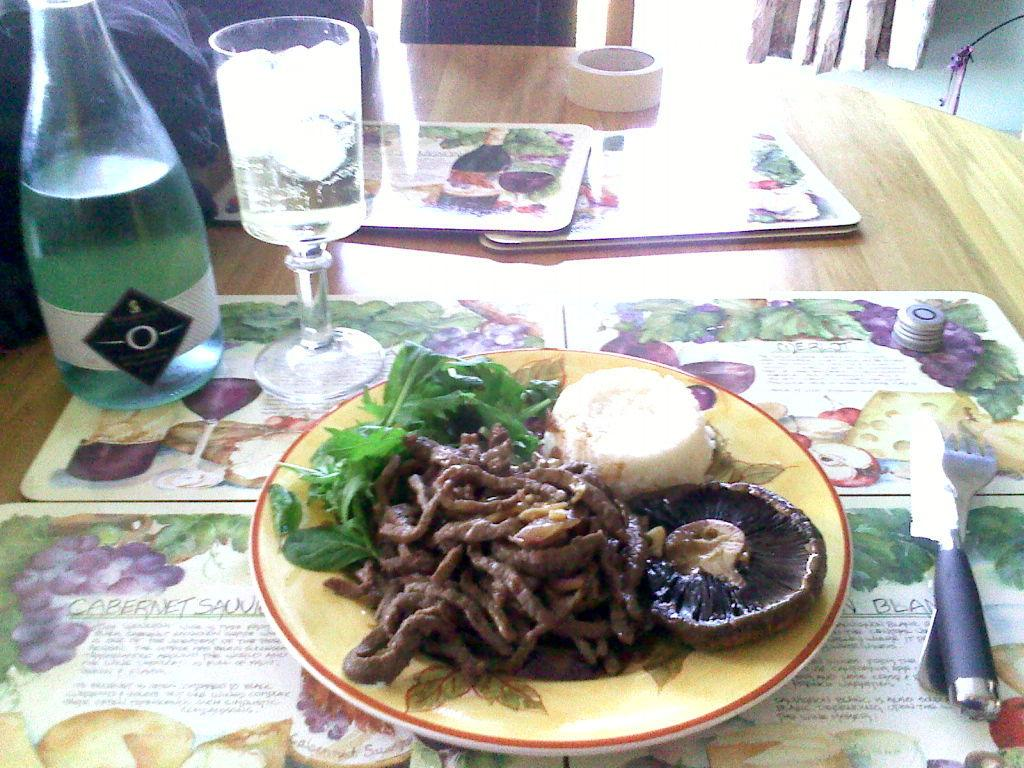What piece of furniture is present in the image? There is a table in the image. What is placed on the table? There is a plate, food, a spoon, a knife, a glass, and bottles on the table. What type of utensils are on the table? There is a spoon and a knife on the table. What is used for drinking in the image? There is a glass on the table for drinking. What is used for holding liquids in the image? There are bottles on the table for holding liquids. What is used to set the table? There are table metals present. What type of grain is being harvested in the image? There is no grain or harvesting activity present in the image; it features a table with various items on it. How many people are lifting the table in the image? There are no people lifting the table in the image; the table is stationary. 